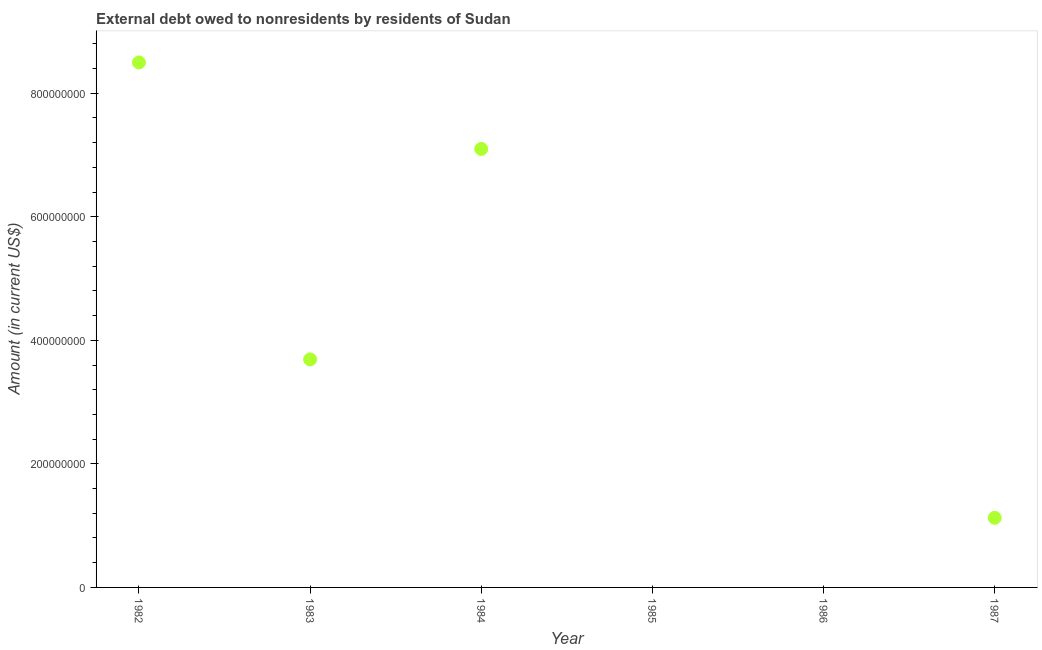What is the debt in 1984?
Provide a succinct answer. 7.10e+08. Across all years, what is the maximum debt?
Your answer should be very brief. 8.50e+08. What is the sum of the debt?
Ensure brevity in your answer.  2.04e+09. What is the difference between the debt in 1982 and 1987?
Provide a short and direct response. 7.37e+08. What is the average debt per year?
Ensure brevity in your answer.  3.40e+08. What is the median debt?
Your answer should be very brief. 2.41e+08. In how many years, is the debt greater than 760000000 US$?
Your answer should be compact. 1. What is the ratio of the debt in 1982 to that in 1984?
Give a very brief answer. 1.2. Is the debt in 1983 less than that in 1984?
Your answer should be compact. Yes. Is the difference between the debt in 1982 and 1984 greater than the difference between any two years?
Offer a terse response. No. What is the difference between the highest and the second highest debt?
Provide a succinct answer. 1.40e+08. What is the difference between the highest and the lowest debt?
Your answer should be very brief. 8.50e+08. In how many years, is the debt greater than the average debt taken over all years?
Offer a terse response. 3. Does the debt monotonically increase over the years?
Keep it short and to the point. No. How many years are there in the graph?
Your answer should be very brief. 6. Are the values on the major ticks of Y-axis written in scientific E-notation?
Your answer should be very brief. No. Does the graph contain any zero values?
Give a very brief answer. Yes. What is the title of the graph?
Your response must be concise. External debt owed to nonresidents by residents of Sudan. What is the label or title of the Y-axis?
Provide a succinct answer. Amount (in current US$). What is the Amount (in current US$) in 1982?
Keep it short and to the point. 8.50e+08. What is the Amount (in current US$) in 1983?
Your answer should be compact. 3.69e+08. What is the Amount (in current US$) in 1984?
Offer a very short reply. 7.10e+08. What is the Amount (in current US$) in 1985?
Your answer should be very brief. 0. What is the Amount (in current US$) in 1986?
Keep it short and to the point. 0. What is the Amount (in current US$) in 1987?
Your answer should be compact. 1.13e+08. What is the difference between the Amount (in current US$) in 1982 and 1983?
Make the answer very short. 4.81e+08. What is the difference between the Amount (in current US$) in 1982 and 1984?
Offer a terse response. 1.40e+08. What is the difference between the Amount (in current US$) in 1982 and 1987?
Your response must be concise. 7.37e+08. What is the difference between the Amount (in current US$) in 1983 and 1984?
Your answer should be compact. -3.41e+08. What is the difference between the Amount (in current US$) in 1983 and 1987?
Offer a terse response. 2.56e+08. What is the difference between the Amount (in current US$) in 1984 and 1987?
Your answer should be compact. 5.97e+08. What is the ratio of the Amount (in current US$) in 1982 to that in 1983?
Offer a very short reply. 2.3. What is the ratio of the Amount (in current US$) in 1982 to that in 1984?
Your answer should be compact. 1.2. What is the ratio of the Amount (in current US$) in 1982 to that in 1987?
Offer a terse response. 7.54. What is the ratio of the Amount (in current US$) in 1983 to that in 1984?
Offer a very short reply. 0.52. What is the ratio of the Amount (in current US$) in 1983 to that in 1987?
Offer a very short reply. 3.27. What is the ratio of the Amount (in current US$) in 1984 to that in 1987?
Your response must be concise. 6.3. 